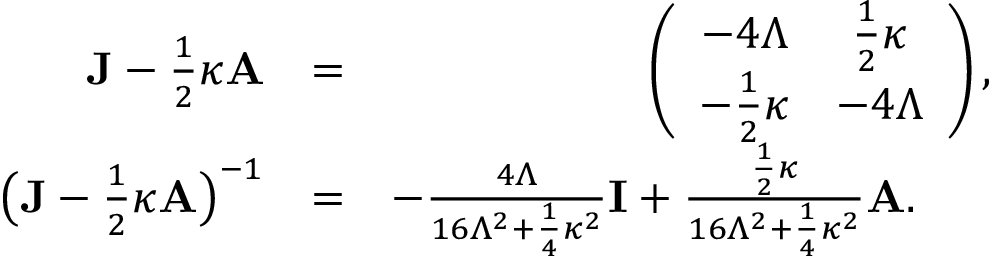Convert formula to latex. <formula><loc_0><loc_0><loc_500><loc_500>\begin{array} { r l r } { { J } - \frac { 1 } { 2 } \kappa { A } } & { = } & { \left ( \begin{array} { c c } { - 4 \Lambda } & { \frac { 1 } { 2 } \kappa } \\ { - \frac { 1 } { 2 } \kappa } & { - 4 \Lambda } \end{array} \right ) , } \\ { \left ( { J } - \frac { 1 } { 2 } \kappa { A } \right ) ^ { - 1 } } & { = } & { - \frac { 4 \Lambda } { 1 6 \Lambda ^ { 2 } + \frac { 1 } { 4 } \kappa ^ { 2 } } { I } + \frac { \frac { 1 } { 2 } \kappa } { 1 6 \Lambda ^ { 2 } + \frac { 1 } { 4 } \kappa ^ { 2 } } { A } . \quad \ } \end{array}</formula> 